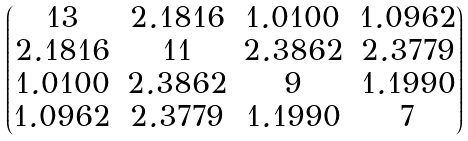<formula> <loc_0><loc_0><loc_500><loc_500>\begin{pmatrix} 1 3 & 2 . 1 8 1 6 & 1 . 0 1 0 0 & 1 . 0 9 6 2 \\ 2 . 1 8 1 6 & 1 1 & 2 . 3 8 6 2 & 2 . 3 7 7 9 \\ 1 . 0 1 0 0 & 2 . 3 8 6 2 & 9 & 1 . 1 9 9 0 \\ 1 . 0 9 6 2 & 2 . 3 7 7 9 & 1 . 1 9 9 0 & 7 \end{pmatrix}</formula> 